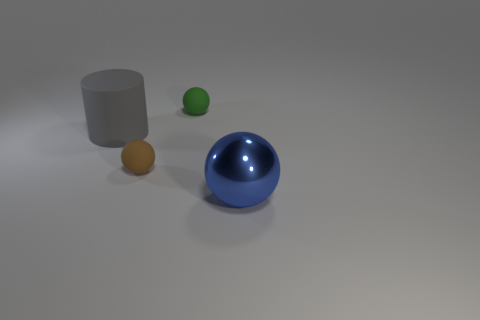Add 2 green metallic spheres. How many objects exist? 6 Subtract all cylinders. How many objects are left? 3 Add 1 green rubber objects. How many green rubber objects exist? 2 Subtract 0 yellow spheres. How many objects are left? 4 Subtract all big purple blocks. Subtract all green rubber things. How many objects are left? 3 Add 4 gray rubber cylinders. How many gray rubber cylinders are left? 5 